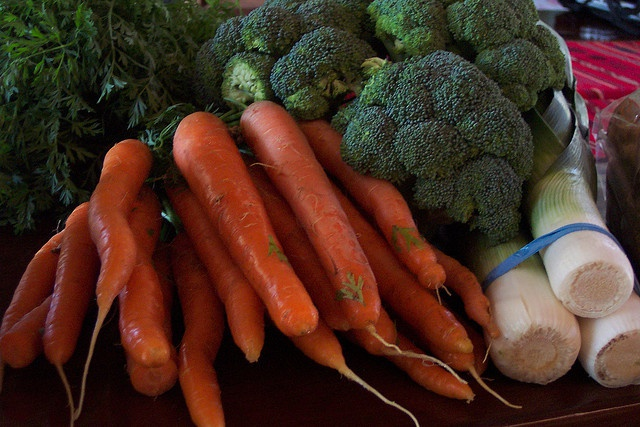Describe the objects in this image and their specific colors. I can see carrot in darkgreen, maroon, brown, and black tones, broccoli in darkgreen, black, and teal tones, broccoli in darkgreen, black, and gray tones, broccoli in darkgreen, black, and teal tones, and broccoli in darkgreen, black, gray, and teal tones in this image. 